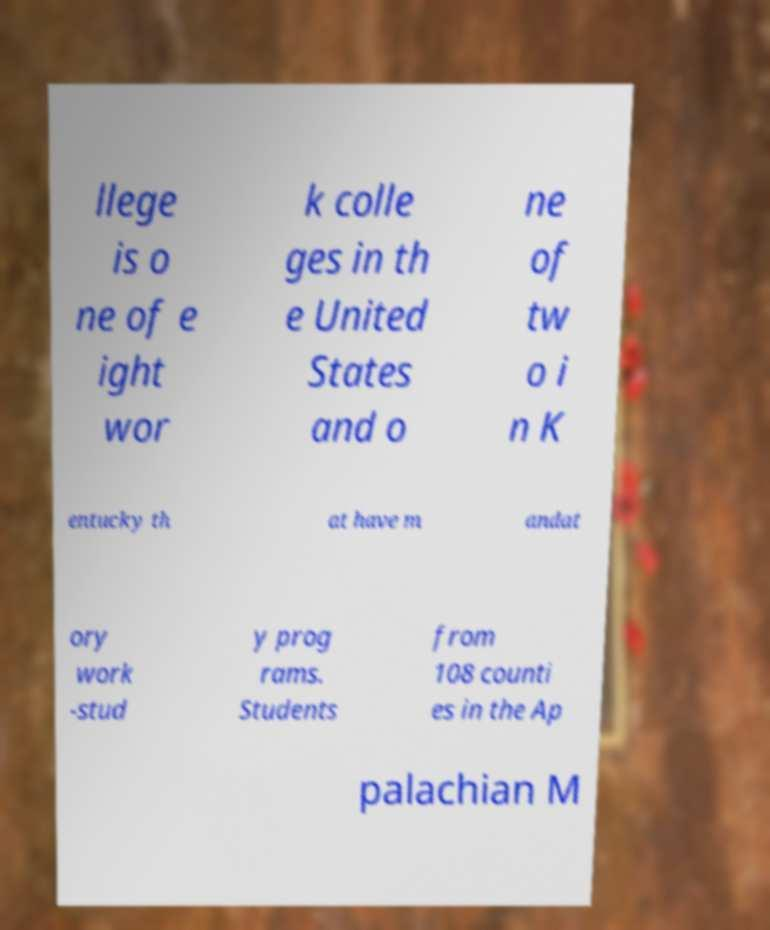What messages or text are displayed in this image? I need them in a readable, typed format. llege is o ne of e ight wor k colle ges in th e United States and o ne of tw o i n K entucky th at have m andat ory work -stud y prog rams. Students from 108 counti es in the Ap palachian M 